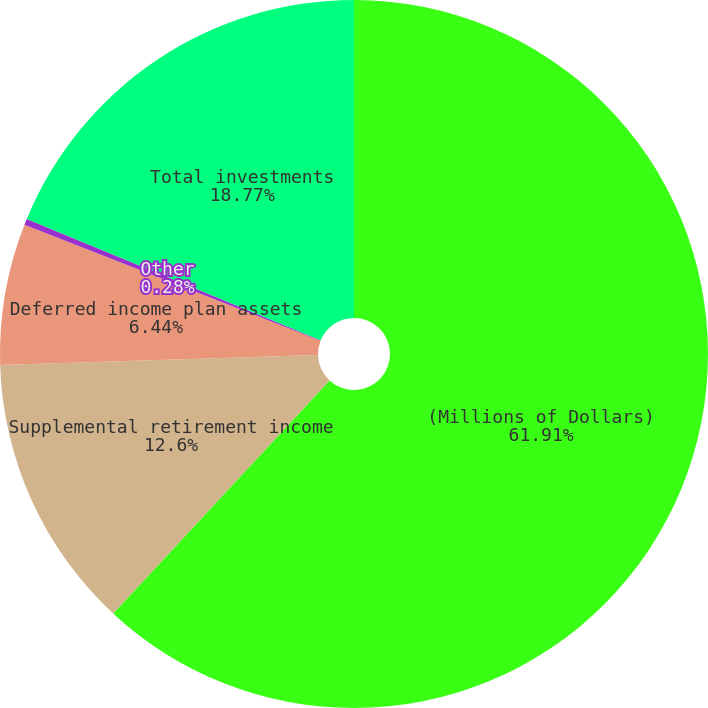Convert chart to OTSL. <chart><loc_0><loc_0><loc_500><loc_500><pie_chart><fcel>(Millions of Dollars)<fcel>Supplemental retirement income<fcel>Deferred income plan assets<fcel>Other<fcel>Total investments<nl><fcel>61.91%<fcel>12.6%<fcel>6.44%<fcel>0.28%<fcel>18.77%<nl></chart> 